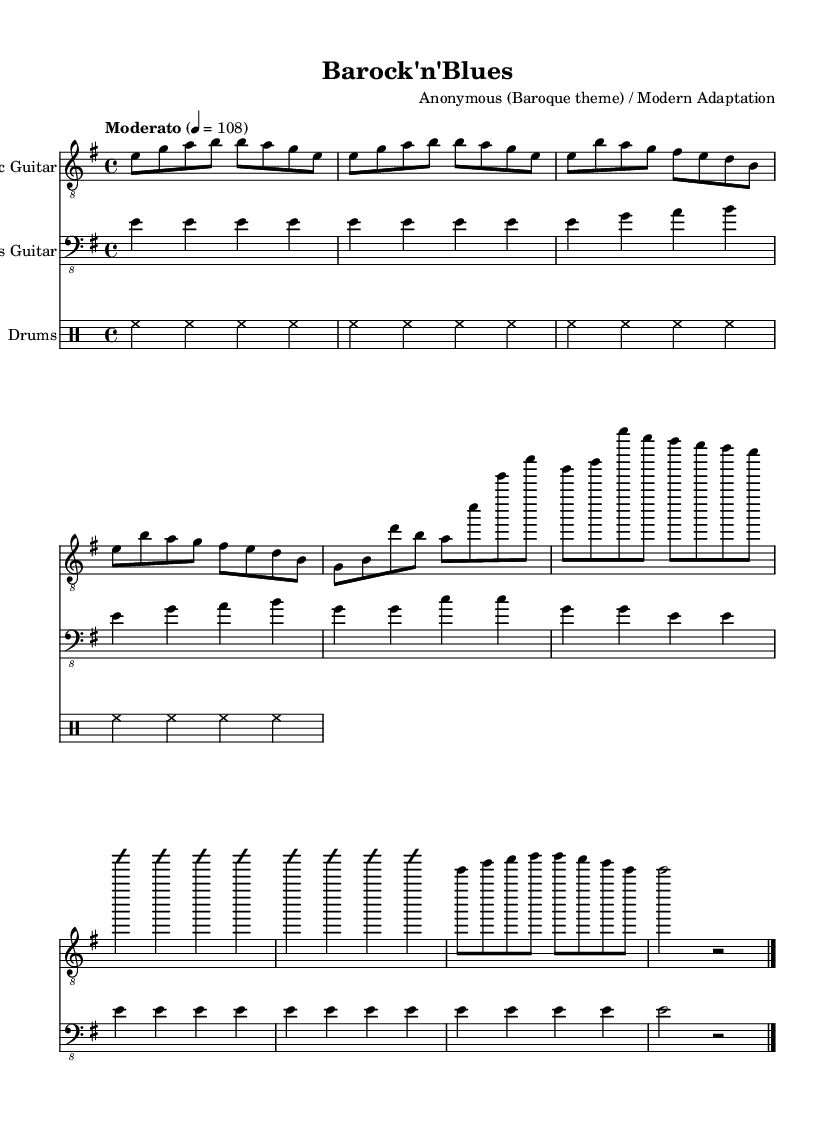what is the key signature of this music? The key signature is E minor, which has one sharp (F#) and is indicated at the beginning of the staff.
Answer: E minor what is the time signature of this music? The time signature is 4/4, indicated at the beginning of the score, meaning there are four beats in each measure.
Answer: 4/4 what is the tempo marking of this piece? The tempo marking indicates that the piece should be played at a moderate speed of 108 beats per minute, which provides a clear reference for the performer.
Answer: Moderato 108 how many measures are in the verse section? The verse section consists of two measures as indicated by the grouping of the notes in that section.
Answer: 2 which instruments are featured in the score? The score features an Electric Guitar, Bass Guitar, and Drums, as indicated by the respective labels on each staff.
Answer: Electric Guitar, Bass Guitar, and Drums what is the main rhythmic pattern used in the drums part? The main rhythmic pattern in the drums part is a standard blues shuffle, which typically emphasizes a consistent groove with swung eighth notes.
Answer: Blues shuffle what improvisational technique is indicated in the solo section? The solo section uses the improvisation technique labeled as 'improvisationOn' and 'improvisationOff', allowing for creative expression within that portion of the music.
Answer: Improvisation 